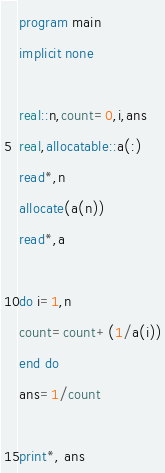<code> <loc_0><loc_0><loc_500><loc_500><_FORTRAN_>program main
implicit none

real::n,count=0,i,ans
real,allocatable::a(:)
read*,n
allocate(a(n))
read*,a

do i=1,n
count=count+(1/a(i))
end do
ans=1/count

print*, ans

</code> 